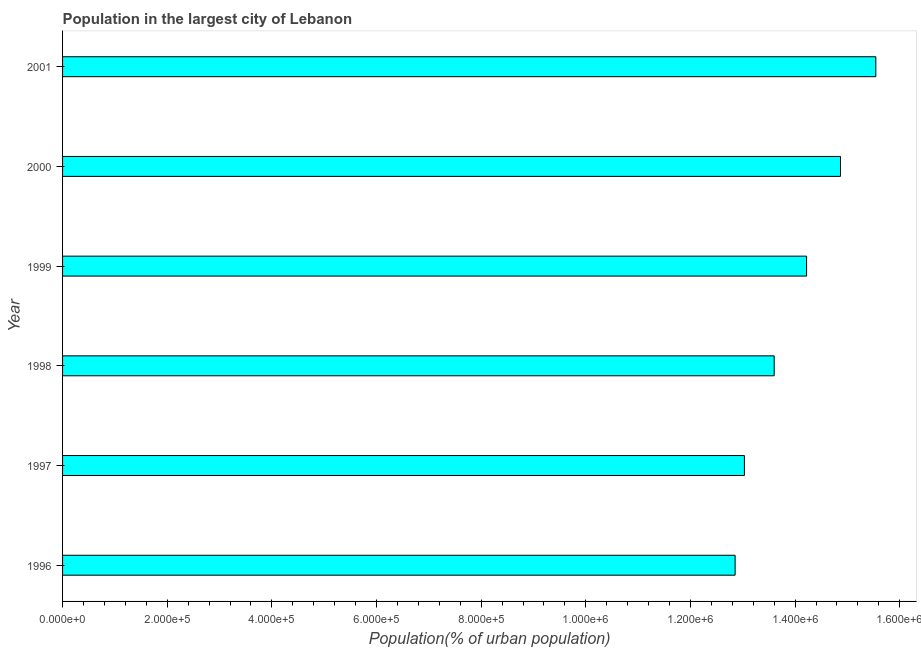Does the graph contain any zero values?
Keep it short and to the point. No. What is the title of the graph?
Your response must be concise. Population in the largest city of Lebanon. What is the label or title of the X-axis?
Provide a succinct answer. Population(% of urban population). What is the population in largest city in 1999?
Keep it short and to the point. 1.42e+06. Across all years, what is the maximum population in largest city?
Offer a terse response. 1.55e+06. Across all years, what is the minimum population in largest city?
Keep it short and to the point. 1.29e+06. What is the sum of the population in largest city?
Your answer should be very brief. 8.41e+06. What is the difference between the population in largest city in 1999 and 2001?
Provide a succinct answer. -1.32e+05. What is the average population in largest city per year?
Ensure brevity in your answer.  1.40e+06. What is the median population in largest city?
Offer a very short reply. 1.39e+06. Is the difference between the population in largest city in 2000 and 2001 greater than the difference between any two years?
Give a very brief answer. No. What is the difference between the highest and the second highest population in largest city?
Keep it short and to the point. 6.76e+04. What is the difference between the highest and the lowest population in largest city?
Provide a short and direct response. 2.69e+05. In how many years, is the population in largest city greater than the average population in largest city taken over all years?
Provide a short and direct response. 3. What is the Population(% of urban population) of 1996?
Offer a very short reply. 1.29e+06. What is the Population(% of urban population) of 1997?
Keep it short and to the point. 1.30e+06. What is the Population(% of urban population) of 1998?
Ensure brevity in your answer.  1.36e+06. What is the Population(% of urban population) of 1999?
Keep it short and to the point. 1.42e+06. What is the Population(% of urban population) in 2000?
Provide a succinct answer. 1.49e+06. What is the Population(% of urban population) of 2001?
Give a very brief answer. 1.55e+06. What is the difference between the Population(% of urban population) in 1996 and 1997?
Your answer should be very brief. -1.77e+04. What is the difference between the Population(% of urban population) in 1996 and 1998?
Offer a very short reply. -7.47e+04. What is the difference between the Population(% of urban population) in 1996 and 1999?
Give a very brief answer. -1.37e+05. What is the difference between the Population(% of urban population) in 1996 and 2000?
Your answer should be compact. -2.01e+05. What is the difference between the Population(% of urban population) in 1996 and 2001?
Your answer should be compact. -2.69e+05. What is the difference between the Population(% of urban population) in 1997 and 1998?
Give a very brief answer. -5.69e+04. What is the difference between the Population(% of urban population) in 1997 and 1999?
Your response must be concise. -1.19e+05. What is the difference between the Population(% of urban population) in 1997 and 2000?
Your answer should be compact. -1.84e+05. What is the difference between the Population(% of urban population) in 1997 and 2001?
Offer a terse response. -2.51e+05. What is the difference between the Population(% of urban population) in 1998 and 1999?
Offer a very short reply. -6.19e+04. What is the difference between the Population(% of urban population) in 1998 and 2000?
Give a very brief answer. -1.27e+05. What is the difference between the Population(% of urban population) in 1998 and 2001?
Your answer should be compact. -1.94e+05. What is the difference between the Population(% of urban population) in 1999 and 2000?
Give a very brief answer. -6.48e+04. What is the difference between the Population(% of urban population) in 1999 and 2001?
Your answer should be very brief. -1.32e+05. What is the difference between the Population(% of urban population) in 2000 and 2001?
Offer a very short reply. -6.76e+04. What is the ratio of the Population(% of urban population) in 1996 to that in 1997?
Your response must be concise. 0.99. What is the ratio of the Population(% of urban population) in 1996 to that in 1998?
Give a very brief answer. 0.94. What is the ratio of the Population(% of urban population) in 1996 to that in 1999?
Keep it short and to the point. 0.9. What is the ratio of the Population(% of urban population) in 1996 to that in 2000?
Offer a terse response. 0.86. What is the ratio of the Population(% of urban population) in 1996 to that in 2001?
Offer a very short reply. 0.83. What is the ratio of the Population(% of urban population) in 1997 to that in 1998?
Provide a short and direct response. 0.96. What is the ratio of the Population(% of urban population) in 1997 to that in 1999?
Keep it short and to the point. 0.92. What is the ratio of the Population(% of urban population) in 1997 to that in 2000?
Offer a terse response. 0.88. What is the ratio of the Population(% of urban population) in 1997 to that in 2001?
Provide a succinct answer. 0.84. What is the ratio of the Population(% of urban population) in 1998 to that in 1999?
Offer a terse response. 0.96. What is the ratio of the Population(% of urban population) in 1998 to that in 2000?
Your response must be concise. 0.92. What is the ratio of the Population(% of urban population) in 1999 to that in 2000?
Your answer should be very brief. 0.96. What is the ratio of the Population(% of urban population) in 1999 to that in 2001?
Keep it short and to the point. 0.92. 